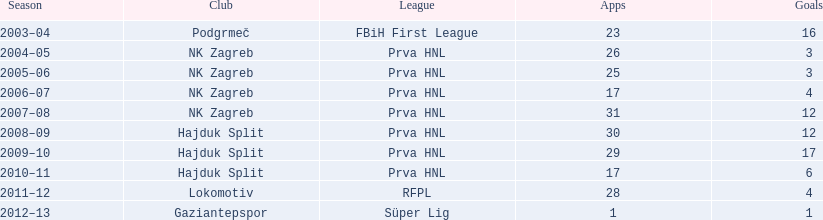After his successful goal against bulgaria in zenica, ibricic scored again in a 7-0 victory less than a month later. which team did he score against in that match? Estonia. 